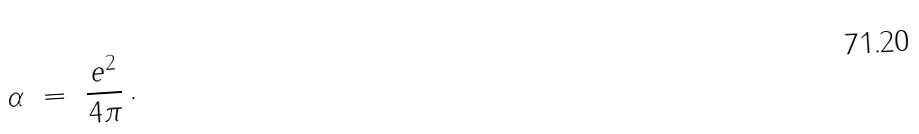Convert formula to latex. <formula><loc_0><loc_0><loc_500><loc_500>\alpha \ = \ \frac { e ^ { 2 } } { 4 \pi } \, .</formula> 